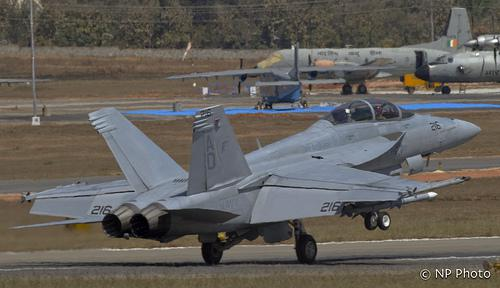Question: what is the color of the jets?
Choices:
A. Silver.
B. Blue.
C. White.
D. Red.
Answer with the letter. Answer: A Question: who is in the pic?
Choices:
A. Parents.
B. Sisters.
C. Elephant.
D. No one.
Answer with the letter. Answer: D Question: what is on the road?
Choices:
A. Lines.
B. Pavement.
C. Dashes.
D. Solid lines.
Answer with the letter. Answer: A Question: when was the pic taken?
Choices:
A. At night.
B. Noon.
C. During the day.
D. Morning.
Answer with the letter. Answer: C 